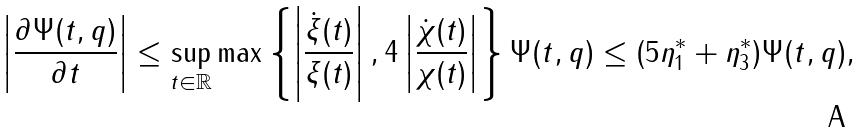<formula> <loc_0><loc_0><loc_500><loc_500>\left | \frac { \partial \Psi ( t , q ) } { \partial t } \right | \leq \sup _ { t \in \mathbb { R } } \max \left \{ \left | \frac { \dot { \xi } ( t ) } { \xi ( t ) } \right | , 4 \left | \frac { \dot { \chi } ( t ) } { \chi ( t ) } \right | \right \} \Psi ( t , q ) \leq ( 5 \eta _ { 1 } ^ { * } + \eta _ { 3 } ^ { * } ) \Psi ( t , q ) ,</formula> 